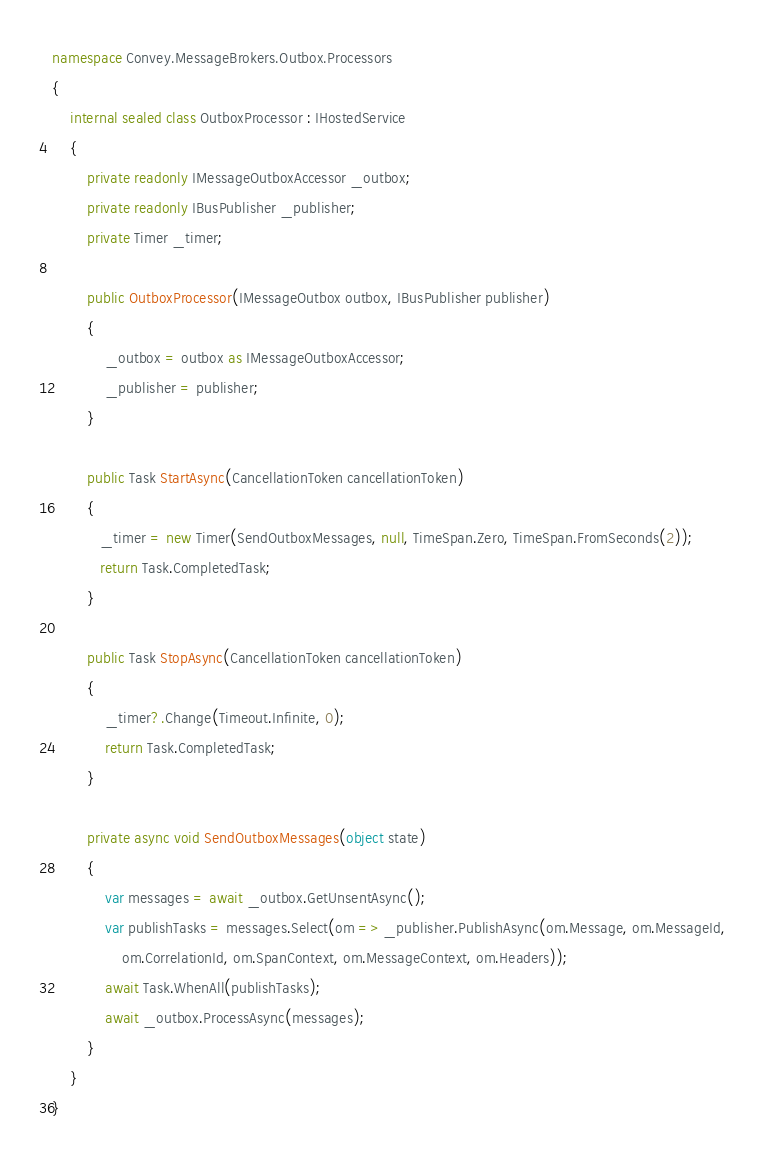<code> <loc_0><loc_0><loc_500><loc_500><_C#_>namespace Convey.MessageBrokers.Outbox.Processors
{
    internal sealed class OutboxProcessor : IHostedService
    {
        private readonly IMessageOutboxAccessor _outbox;
        private readonly IBusPublisher _publisher;
        private Timer _timer;

        public OutboxProcessor(IMessageOutbox outbox, IBusPublisher publisher)
        {
            _outbox = outbox as IMessageOutboxAccessor;
            _publisher = publisher;
        }

        public Task StartAsync(CancellationToken cancellationToken)
        {
           _timer = new Timer(SendOutboxMessages, null, TimeSpan.Zero, TimeSpan.FromSeconds(2));
           return Task.CompletedTask;
        }

        public Task StopAsync(CancellationToken cancellationToken)
        {
            _timer?.Change(Timeout.Infinite, 0);
            return Task.CompletedTask;
        }

        private async void SendOutboxMessages(object state)
        {
            var messages = await _outbox.GetUnsentAsync();
            var publishTasks = messages.Select(om => _publisher.PublishAsync(om.Message, om.MessageId, 
                om.CorrelationId, om.SpanContext, om.MessageContext, om.Headers));
            await Task.WhenAll(publishTasks);
            await _outbox.ProcessAsync(messages);
        }
    }
}</code> 